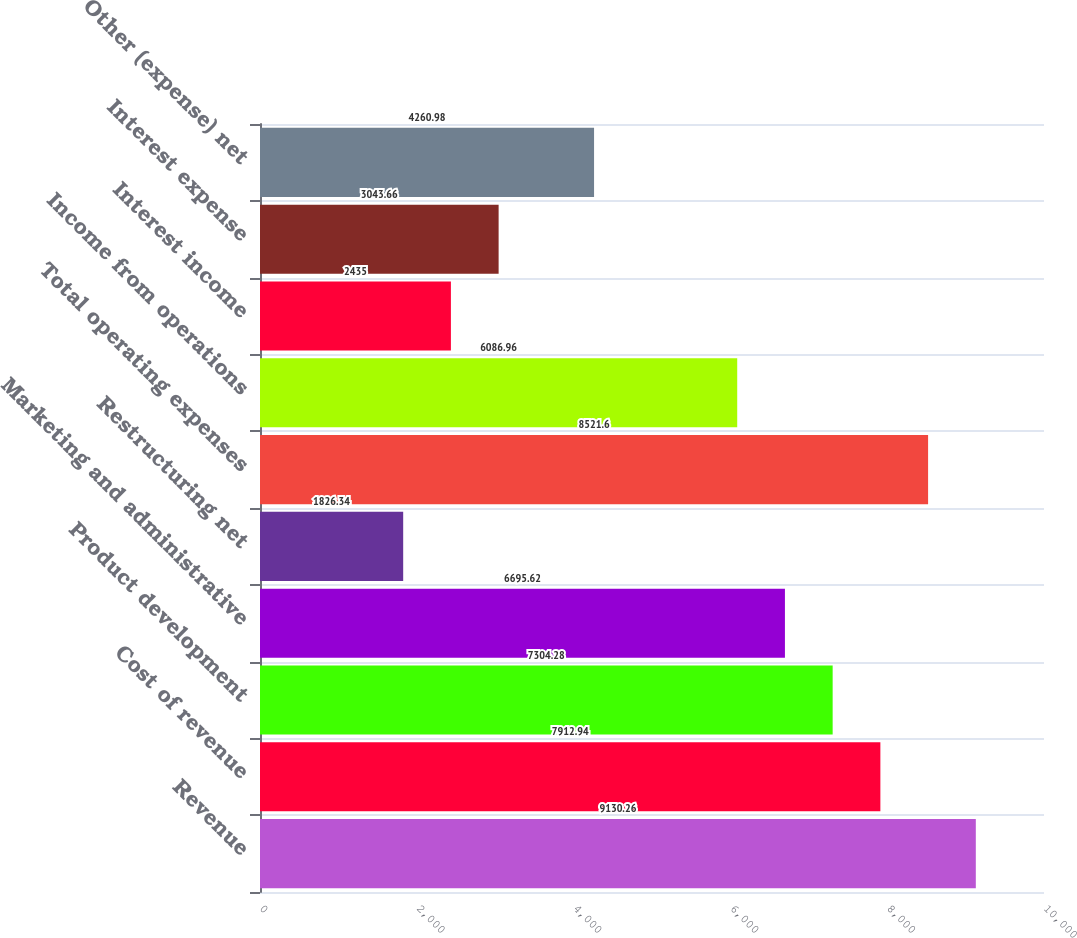<chart> <loc_0><loc_0><loc_500><loc_500><bar_chart><fcel>Revenue<fcel>Cost of revenue<fcel>Product development<fcel>Marketing and administrative<fcel>Restructuring net<fcel>Total operating expenses<fcel>Income from operations<fcel>Interest income<fcel>Interest expense<fcel>Other (expense) net<nl><fcel>9130.26<fcel>7912.94<fcel>7304.28<fcel>6695.62<fcel>1826.34<fcel>8521.6<fcel>6086.96<fcel>2435<fcel>3043.66<fcel>4260.98<nl></chart> 